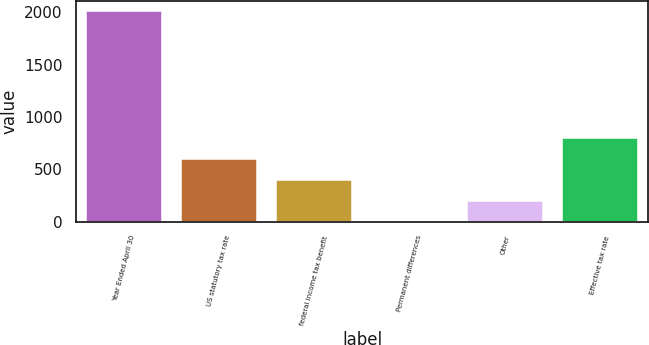<chart> <loc_0><loc_0><loc_500><loc_500><bar_chart><fcel>Year Ended April 30<fcel>US statutory tax rate<fcel>federal income tax benefit<fcel>Permanent differences<fcel>Other<fcel>Effective tax rate<nl><fcel>2007<fcel>602.17<fcel>401.48<fcel>0.1<fcel>200.79<fcel>802.86<nl></chart> 